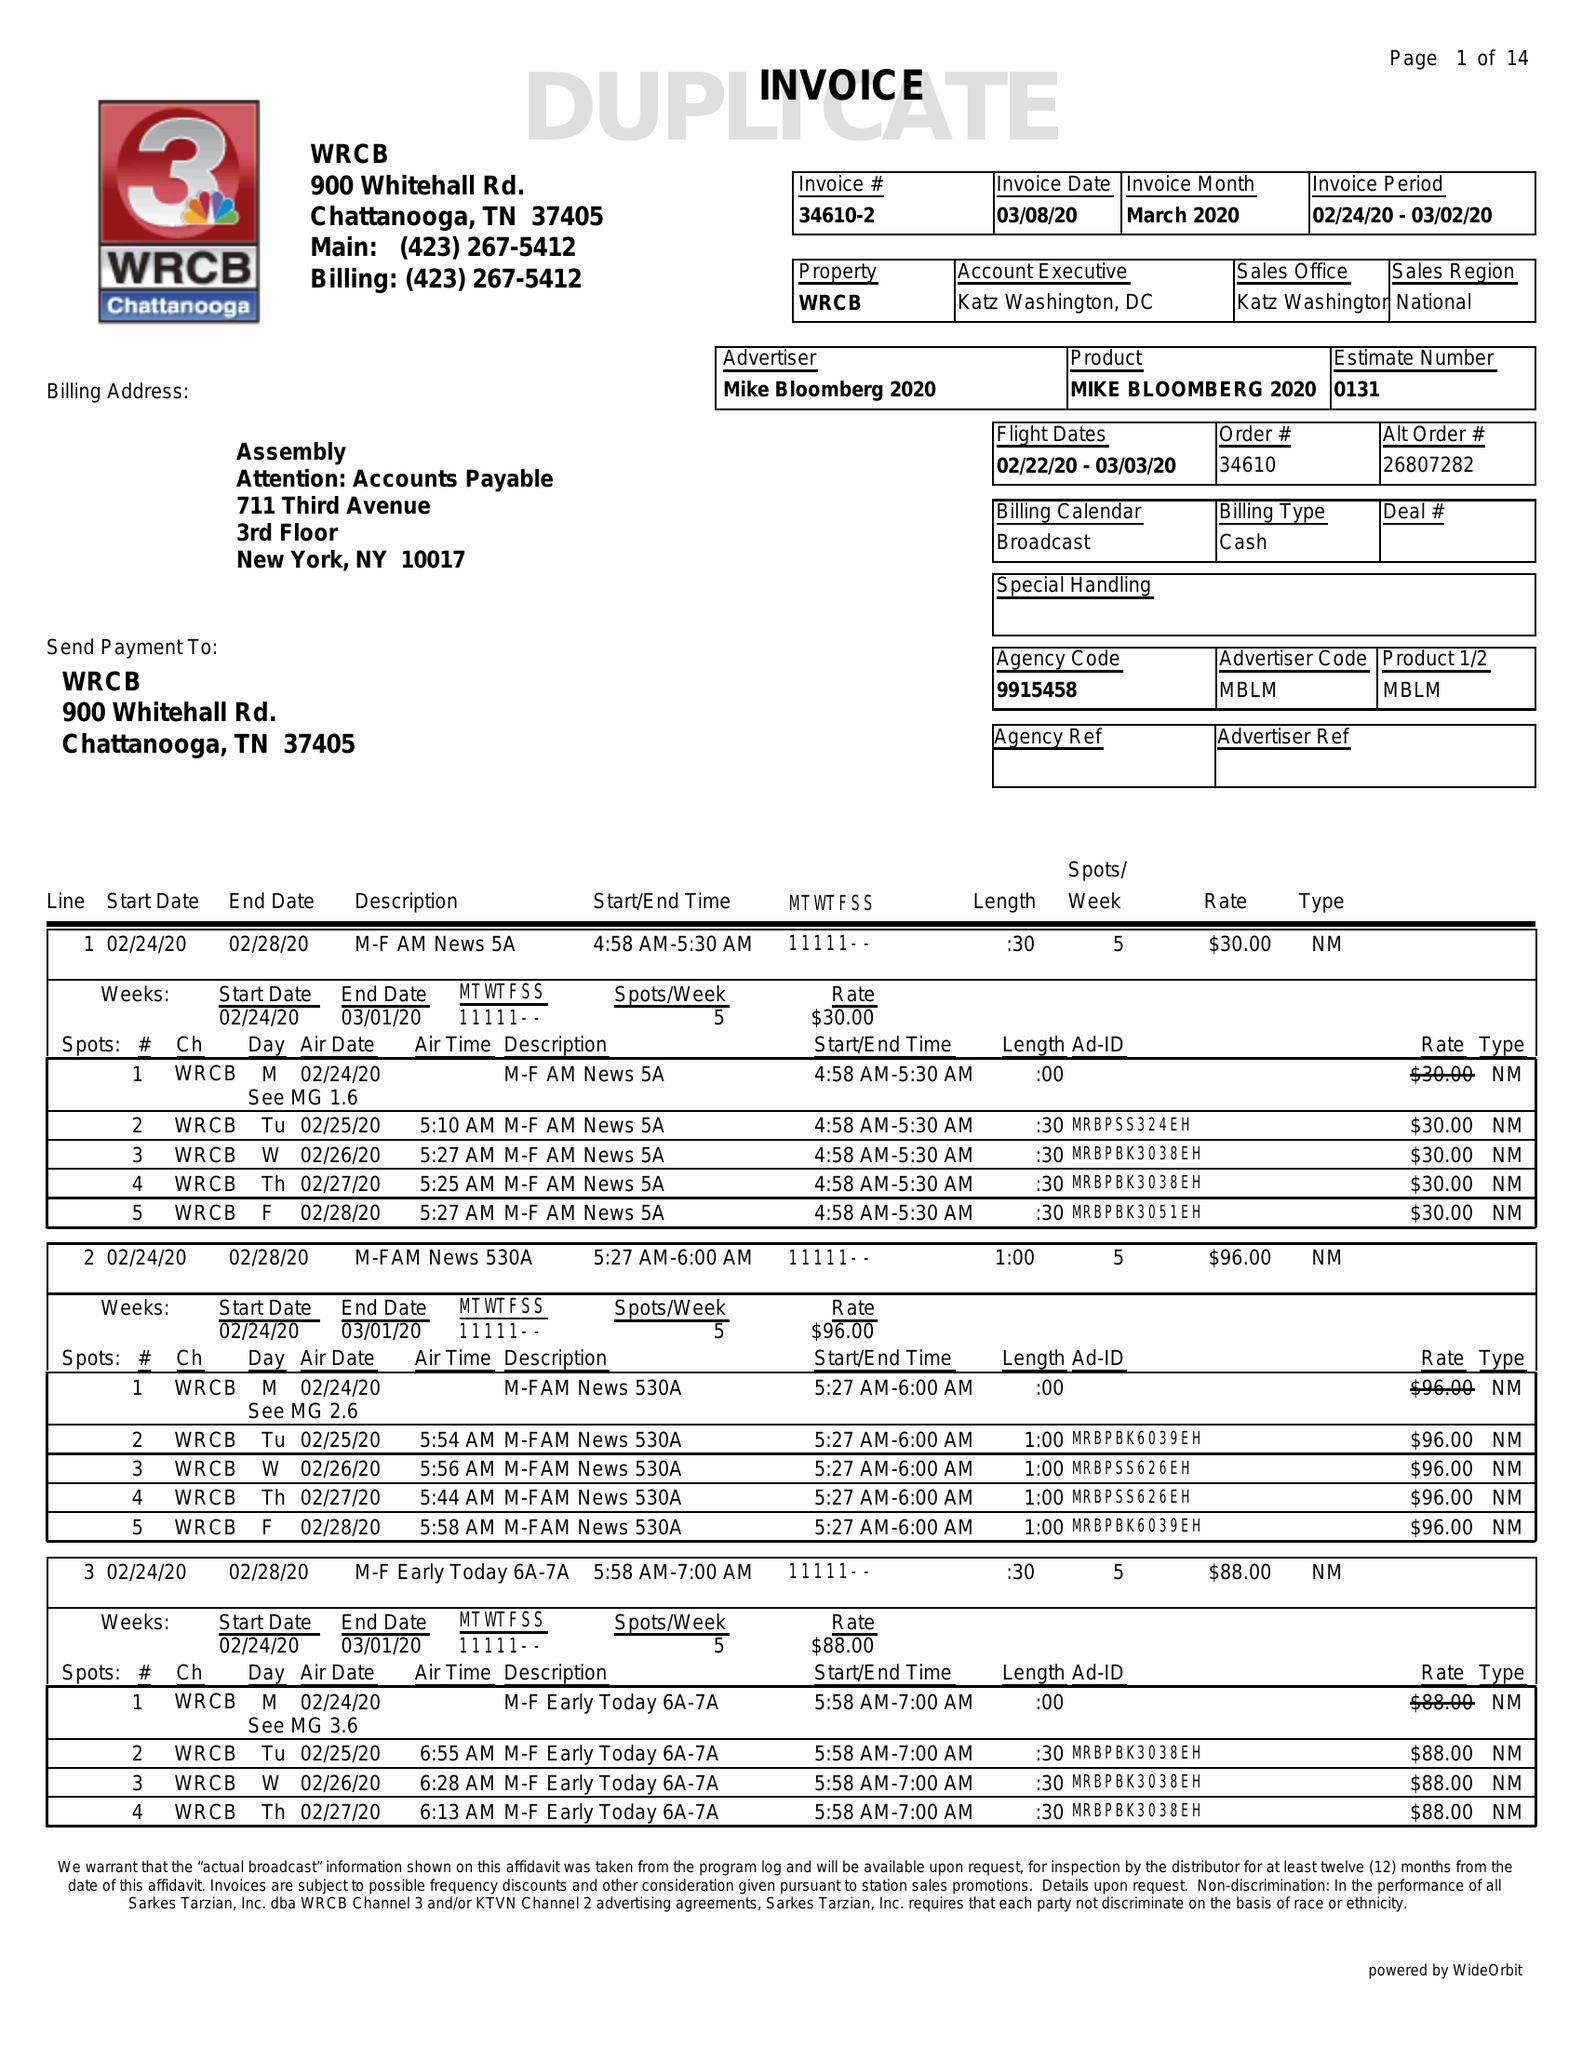What is the value for the contract_num?
Answer the question using a single word or phrase. 34610 